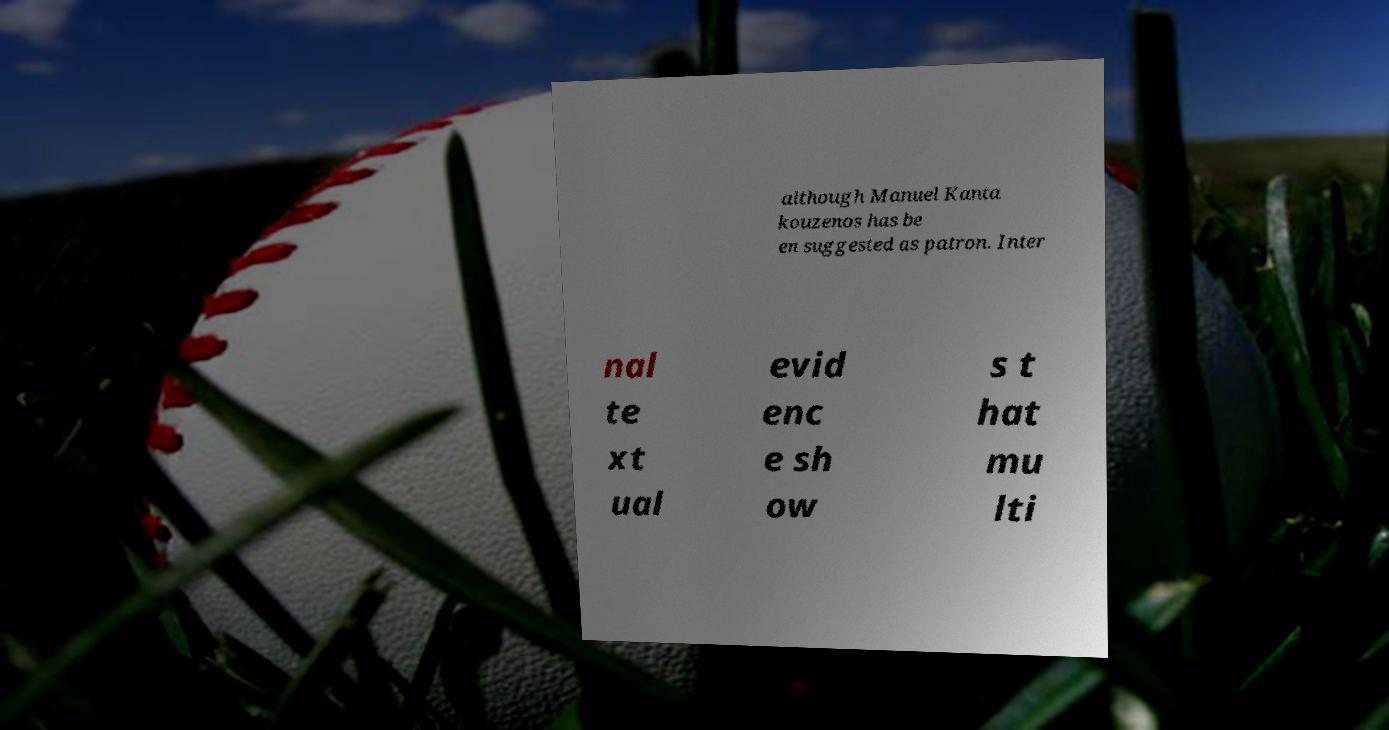I need the written content from this picture converted into text. Can you do that? although Manuel Kanta kouzenos has be en suggested as patron. Inter nal te xt ual evid enc e sh ow s t hat mu lti 